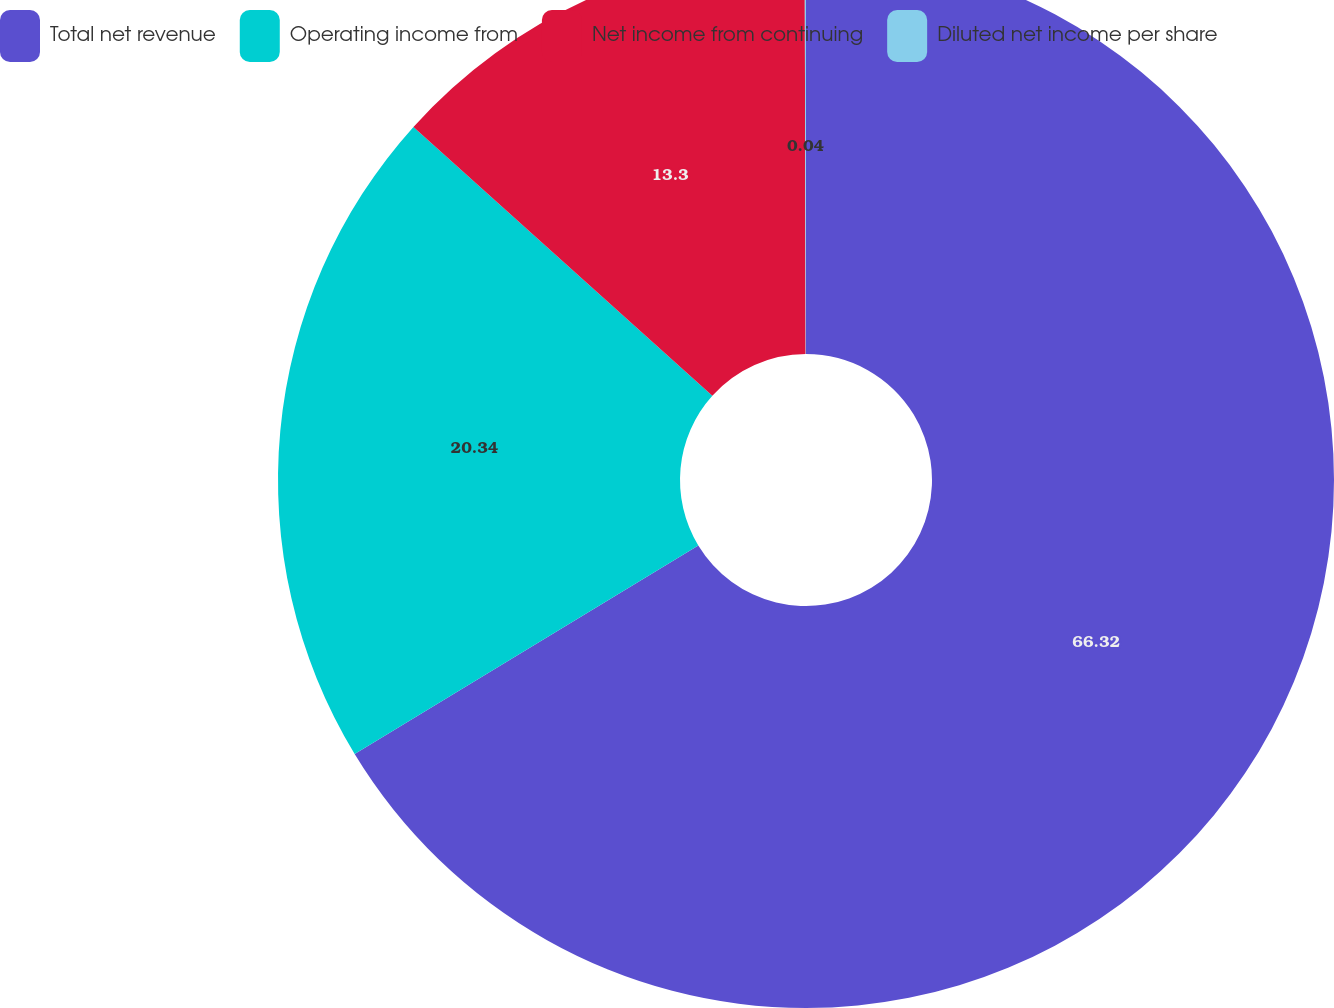Convert chart to OTSL. <chart><loc_0><loc_0><loc_500><loc_500><pie_chart><fcel>Total net revenue<fcel>Operating income from<fcel>Net income from continuing<fcel>Diluted net income per share<nl><fcel>66.31%<fcel>20.34%<fcel>13.3%<fcel>0.04%<nl></chart> 